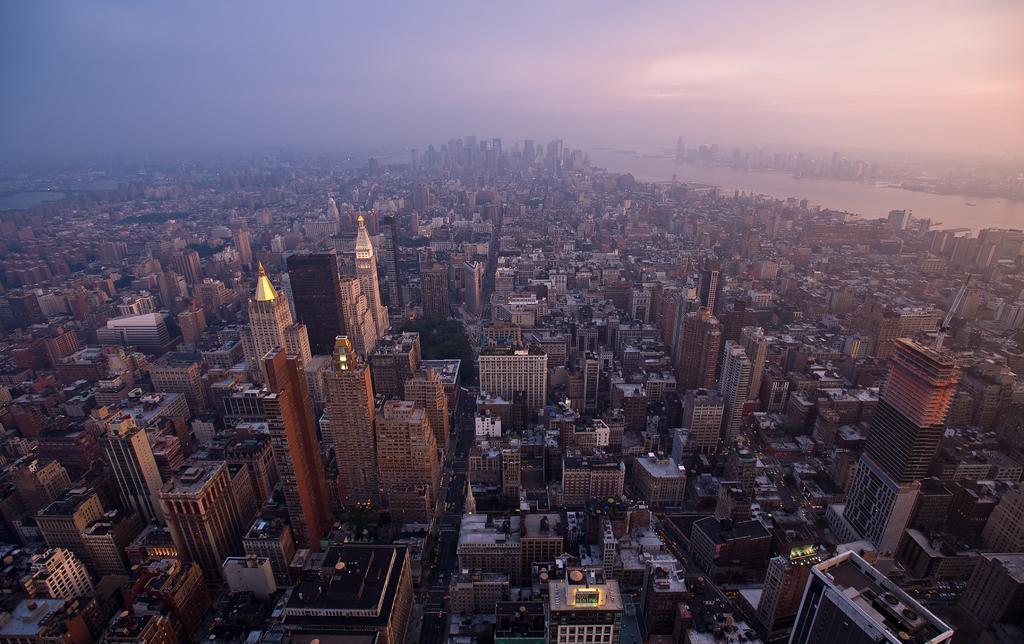Can you describe this image briefly? In this image I can see few buildings. In the background I can see the water and the sky is in blue and white color. 